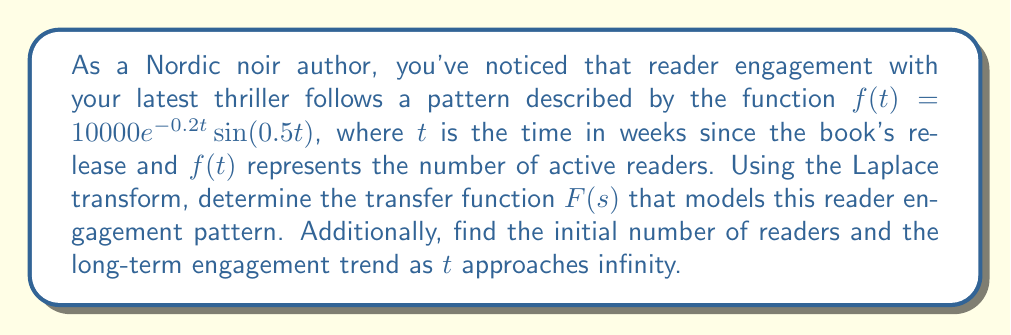Can you answer this question? To solve this problem, we'll follow these steps:

1) First, recall the Laplace transform of $e^{at}\sin(bt)$:

   $\mathcal{L}\{e^{at}\sin(bt)\} = \frac{b}{(s-a)^2 + b^2}$

2) In our case, $a = -0.2$ and $b = 0.5$. We also have a constant factor of 10000. So, we can write:

   $F(s) = \mathcal{L}\{10000e^{-0.2t}\sin(0.5t)\} = 10000 \cdot \frac{0.5}{(s+0.2)^2 + 0.5^2}$

3) Simplifying:

   $F(s) = \frac{5000}{(s+0.2)^2 + 0.25}$

4) This is our transfer function $F(s)$.

5) To find the initial number of readers, we can use the initial value theorem:

   $\lim_{t \to 0} f(t) = \lim_{s \to \infty} sF(s)$

   $\lim_{s \to \infty} s \cdot \frac{5000}{(s+0.2)^2 + 0.25} = \lim_{s \to \infty} \frac{5000s}{s^2 + 0.4s + 0.29} = 0$

6) For the long-term trend, we use the final value theorem:

   $\lim_{t \to \infty} f(t) = \lim_{s \to 0} sF(s)$

   $\lim_{s \to 0} s \cdot \frac{5000}{(s+0.2)^2 + 0.25} = 0$

This indicates that both initially and in the long term, the number of active readers approaches zero.
Answer: The transfer function is $F(s) = \frac{5000}{(s+0.2)^2 + 0.25}$. The initial number of readers is 0, and the long-term engagement trend as $t$ approaches infinity is also 0. 